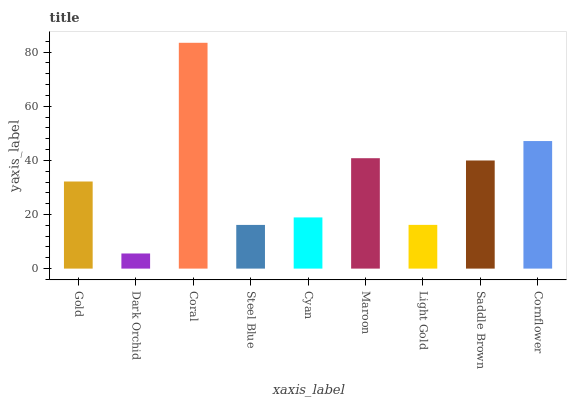Is Dark Orchid the minimum?
Answer yes or no. Yes. Is Coral the maximum?
Answer yes or no. Yes. Is Coral the minimum?
Answer yes or no. No. Is Dark Orchid the maximum?
Answer yes or no. No. Is Coral greater than Dark Orchid?
Answer yes or no. Yes. Is Dark Orchid less than Coral?
Answer yes or no. Yes. Is Dark Orchid greater than Coral?
Answer yes or no. No. Is Coral less than Dark Orchid?
Answer yes or no. No. Is Gold the high median?
Answer yes or no. Yes. Is Gold the low median?
Answer yes or no. Yes. Is Cyan the high median?
Answer yes or no. No. Is Maroon the low median?
Answer yes or no. No. 